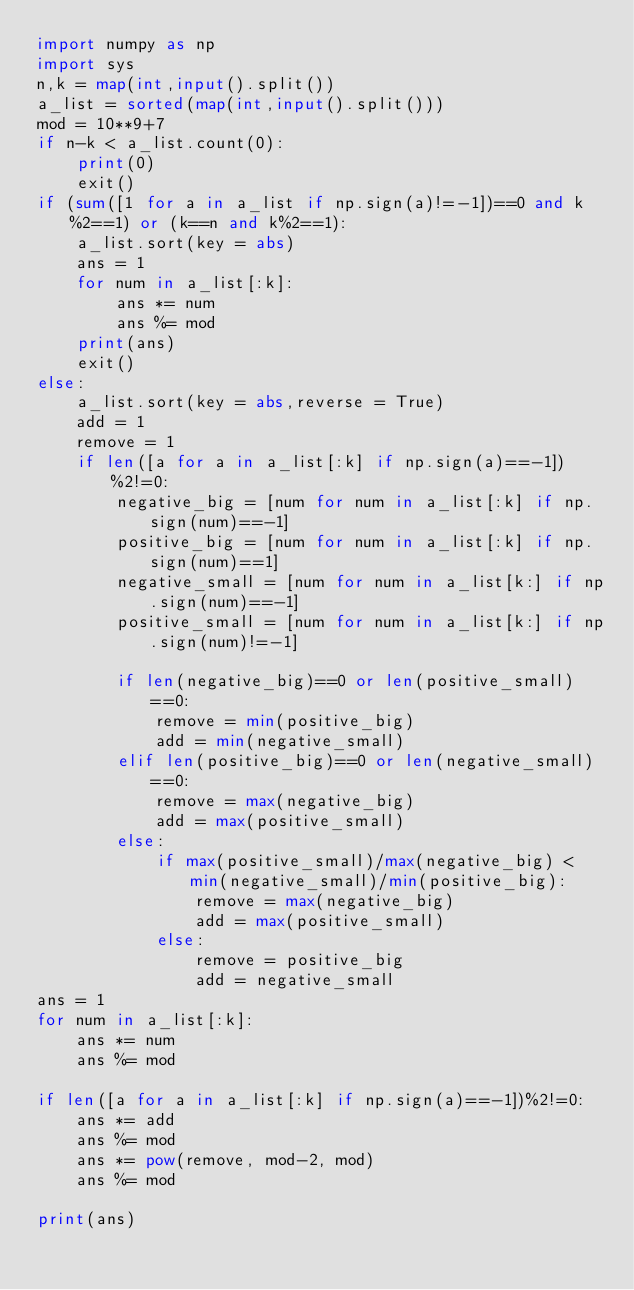Convert code to text. <code><loc_0><loc_0><loc_500><loc_500><_Python_>import numpy as np
import sys
n,k = map(int,input().split())
a_list = sorted(map(int,input().split()))
mod = 10**9+7
if n-k < a_list.count(0):
    print(0)
    exit()
if (sum([1 for a in a_list if np.sign(a)!=-1])==0 and k%2==1) or (k==n and k%2==1):
    a_list.sort(key = abs)
    ans = 1
    for num in a_list[:k]:
        ans *= num
        ans %= mod
    print(ans)
    exit()
else:
    a_list.sort(key = abs,reverse = True)
    add = 1
    remove = 1
    if len([a for a in a_list[:k] if np.sign(a)==-1])%2!=0:
        negative_big = [num for num in a_list[:k] if np.sign(num)==-1]
        positive_big = [num for num in a_list[:k] if np.sign(num)==1]
        negative_small = [num for num in a_list[k:] if np.sign(num)==-1]
        positive_small = [num for num in a_list[k:] if np.sign(num)!=-1]
        
        if len(negative_big)==0 or len(positive_small)==0:
            remove = min(positive_big)
            add = min(negative_small)
        elif len(positive_big)==0 or len(negative_small)==0:
            remove = max(negative_big)
            add = max(positive_small)
        else:
            if max(positive_small)/max(negative_big) < min(negative_small)/min(positive_big):
                remove = max(negative_big)
                add = max(positive_small)
            else:
                remove = positive_big
                add = negative_small
ans = 1
for num in a_list[:k]:
    ans *= num
    ans %= mod
    
if len([a for a in a_list[:k] if np.sign(a)==-1])%2!=0:
    ans *= add
    ans %= mod
    ans *= pow(remove, mod-2, mod)
    ans %= mod

print(ans)</code> 